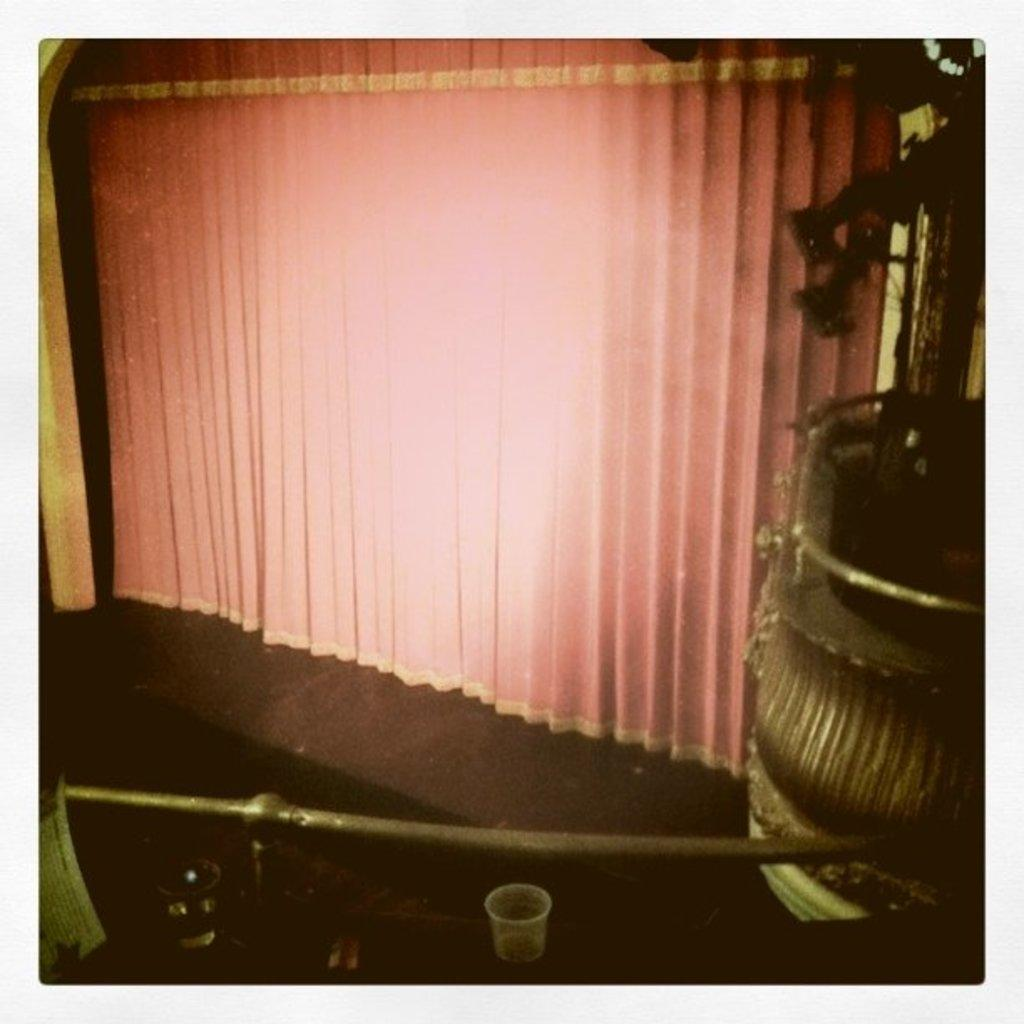What objects are on the table in the image? There are glasses on the table in the image. What can be seen in the background of the image? There is a plant and curtains in the background of the image. What time of day is it in the image, considering the presence of spiders? There are no spiders present in the image, so it is not possible to determine the time of day based on their presence. 